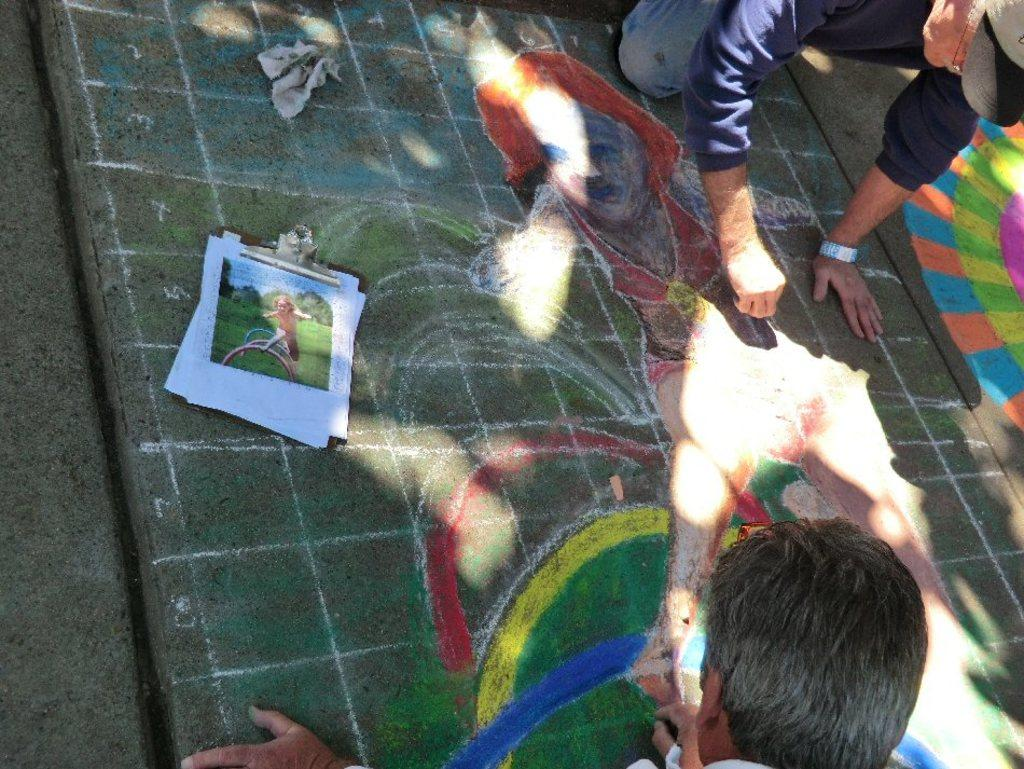Who or what can be seen in the image? There are people in the image. What is on the ground in the image? There is art and objects on the ground in the image. What type of berry is being used as a riddle in the image? There is no berry or riddle present in the image. How many bananas are being held by the people in the image? There is no mention of bananas in the image; the people are not holding any. 